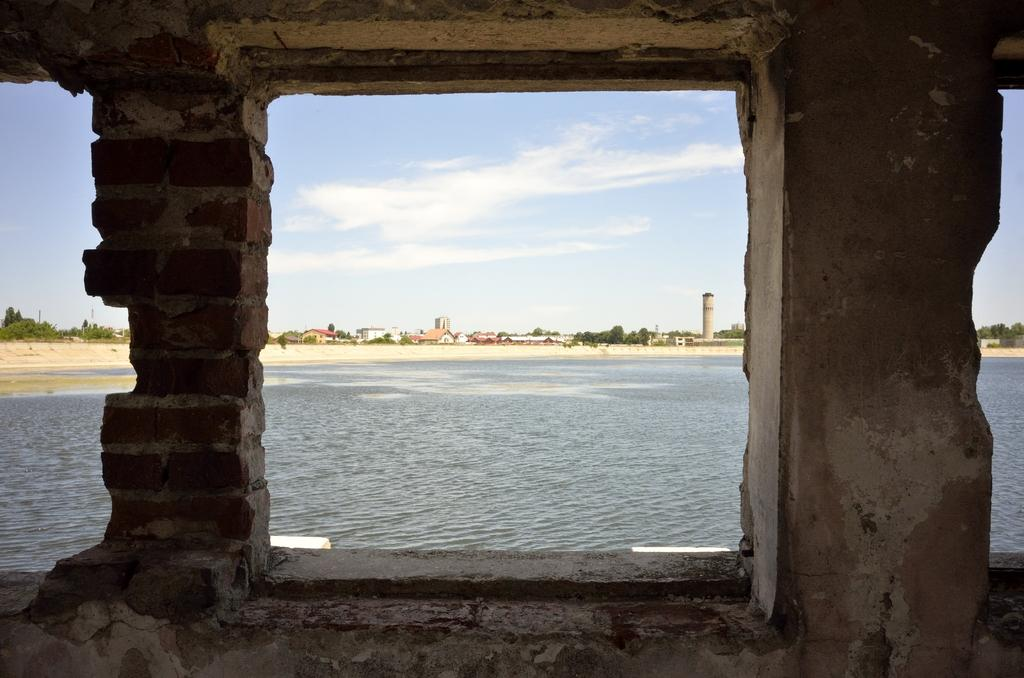What is present on one side of the image? There is a wall in the image. What can be seen through the wall? Water is visible through the wall. What type of natural environment is visible in the background of the image? There are trees in the background of the image. What type of man-made structures are visible in the background of the image? There are houses in the background of the image. What is visible at the top of the image? The sky is clear and visible at the top of the image. Where is the lift located in the image? There is no lift present in the image. What type of ground condition is depicted in the image? The image does not show any ground conditions, as it features a wall with water visible through it and a clear sky in the background. 